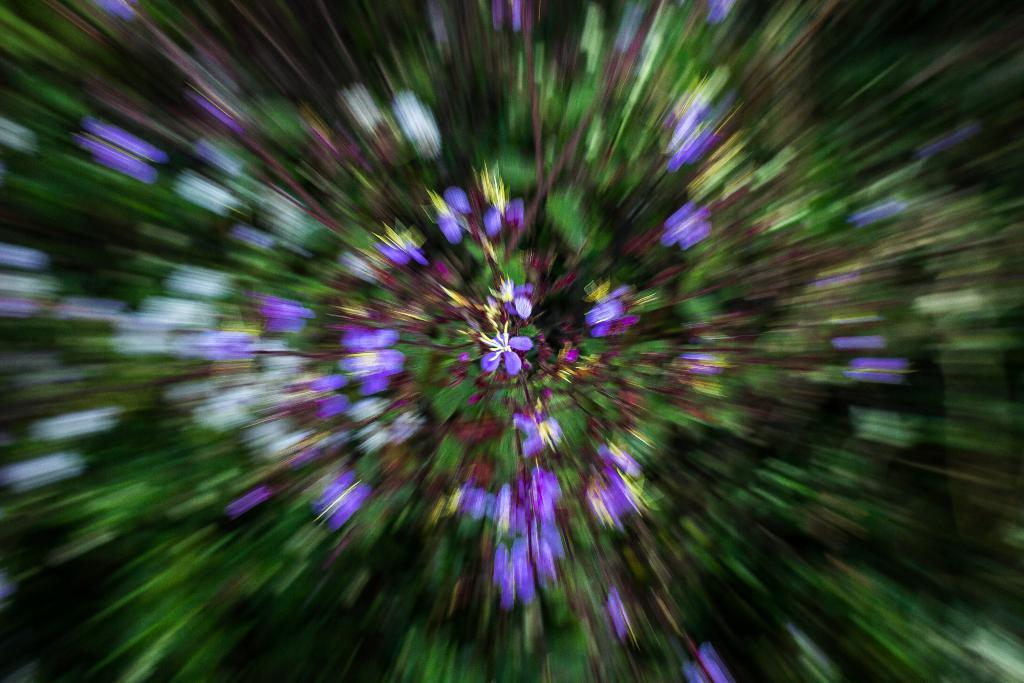What is the main subject of the image? There is a flower in the middle of the image. Can you describe the background of the image? The background of the image is blurry. What type of rock is being used to generate power in the image? There is no rock or power generation present in the image; it features a flower and a blurry background. 